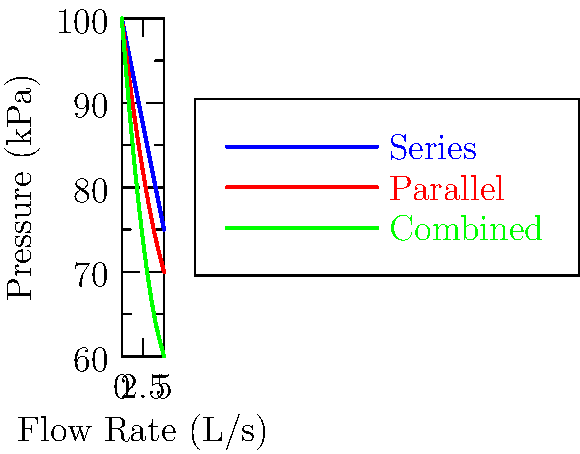Given the pressure-flow rate curves for different pipe configurations in a water distribution system, which configuration would be most suitable for maintaining consistent pressure across various flow rates, thereby minimizing the risk of system failure due to pressure fluctuations? To answer this question, we need to analyze the pressure-flow rate relationships for each configuration:

1. Series configuration (blue line):
   - Pressure drops from 100 kPa to 75 kPa as flow rate increases from 0 to 5 L/s
   - Total pressure drop: 25 kPa
   - Rate of pressure drop: approximately 5 kPa per L/s

2. Parallel configuration (red line):
   - Pressure drops from 100 kPa to 70 kPa as flow rate increases from 0 to 5 L/s
   - Total pressure drop: 30 kPa
   - Rate of pressure drop: approximately 6 kPa per L/s

3. Combined configuration (green line):
   - Pressure drops from 100 kPa to 60 kPa as flow rate increases from 0 to 5 L/s
   - Total pressure drop: 40 kPa
   - Rate of pressure drop: approximately 8 kPa per L/s

For maintaining consistent pressure across various flow rates:

1. We want the configuration with the least pressure drop over the given flow rate range.
2. A smaller pressure drop indicates better pressure consistency.
3. The series configuration (blue line) shows the smallest overall pressure drop (25 kPa) and the most gradual slope.

From a risk management perspective:
- The series configuration provides the most stable pressure across different flow rates.
- This stability reduces the risk of system failure due to pressure fluctuations.
- It allows for more predictable system behavior, which is crucial for creating safe investment strategies in infrastructure projects.

Therefore, the series configuration would be most suitable for maintaining consistent pressure and minimizing risk.
Answer: Series configuration 